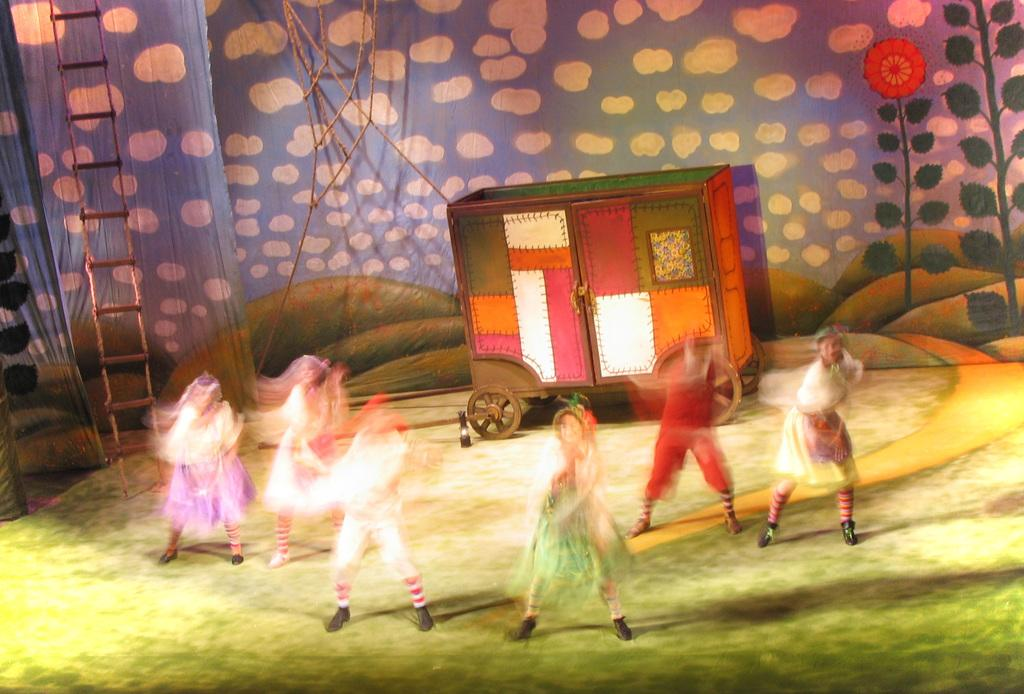What are the people in the foreground of the image doing? The persons in the foreground of the image are dancing. How are the dancers depicted in the image? The persons dancing are blurred. Where is the dancing taking place? The dancing is taking place on the floor. What type of kite is being flown by the dancers in the image? There is no kite present in the image; the persons are dancing on the floor. How many buns are being served to the dancers in the image? There is no mention of buns or food in the image; the focus is on the dancing and the background elements. 